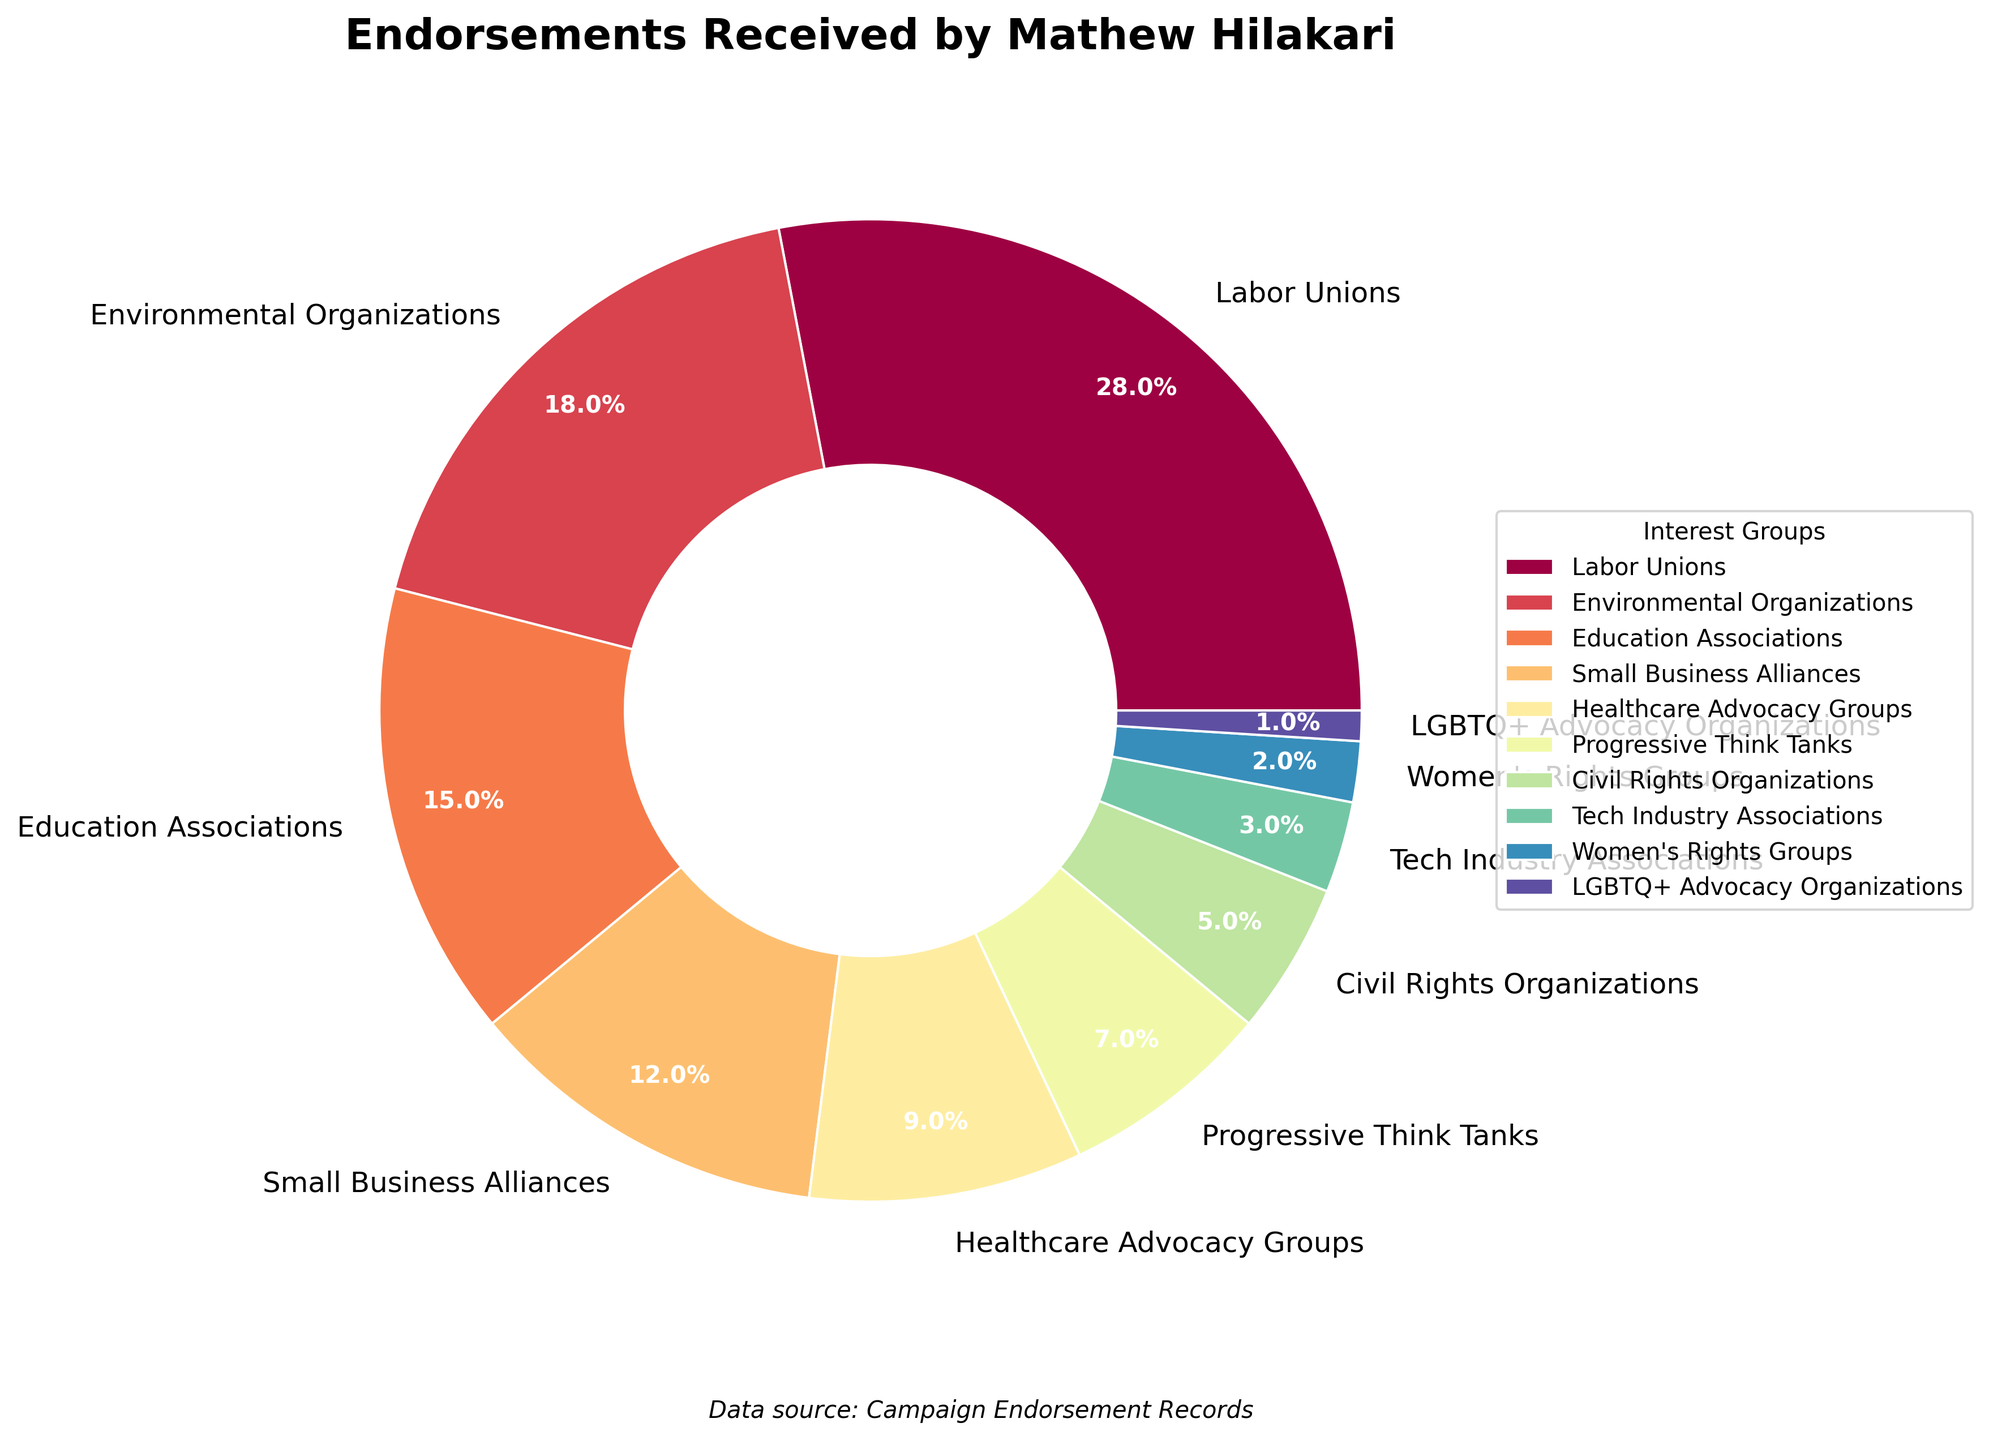Which interest group has the highest percentage of endorsements for Mathew Hilakari? The largest segment on the pie chart represents the highest percentage, which is 28% and labeled as Labor Unions.
Answer: Labor Unions What is the combined percentage of endorsements received from Labor Unions and Environmental Organizations? The pie chart shows Labor Unions at 28% and Environmental Organizations at 18%. Adding these together: 28% + 18% = 46%.
Answer: 46% Which group has a smaller endorsement percentage, Education Associations or Small Business Alliances? By comparing the segments and their labels, Education Associations are at 15% and Small Business Alliances at 12%. 12% is smaller than 15%.
Answer: Small Business Alliances What is the total percentage of endorsements from groups with less than 5%? Find all groups with less than 5%: Civil Rights Organizations (5%), Tech Industry Associations (3%), Women's Rights Groups (2%), and LGBTQ+ Advocacy Organizations (1%). Add the percentages: 3% + 2% + 1% = 6%.
Answer: 6% Does the pie chart have more groups with endorsements above or below 10%? Count the groups above 10%: 4 (Labor Unions, Environmental Organizations, Education Associations, Small Business Alliances). Count the groups below 10%: 6 (Healthcare Advocacy Groups, Progressive Think Tanks, Civil Rights Organizations, Tech Industry Associations, Women's Rights Groups, LGBTQ+ Advocacy Organizations). There are more groups below 10%.
Answer: below 10% Which category has exactly half the percentage of endorsements as Labor Unions? Labor Unions have 28%. Half of 28% is 14%. By visual comparison, there is no group with exactly 14%, but Education Associations have 15%, which is the closest.
Answer: None (closest is Education Associations at 15%) What percentage of endorsements do Progressive Think Tanks and Civil Rights Organizations combined account for? Progressive Think Tanks have 7% and Civil Rights Organizations have 5%. Adding these together: 7% + 5% = 12%.
Answer: 12% Which categories have less endorsements than Healthcare Advocacy Groups but more than Women's Rights Groups? Healthcare Advocacy Groups have 9%. Women's Rights Groups have 2%. The relevant categories are Progressive Think Tanks (7%) and Civil Rights Organizations (5%).
Answer: Progressive Think Tanks and Civil Rights Organizations How many groups have endorsements between 5% and 20%? Identify the groups in the range 5% – 20%: Environmental Organizations (18%), Education Associations (15%), Healthcare Advocacy Groups (9%), Progressive Think Tanks (7%), Civil Rights Organizations (5%). Count of these groups: 5.
Answer: 5 